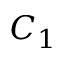<formula> <loc_0><loc_0><loc_500><loc_500>C _ { 1 }</formula> 